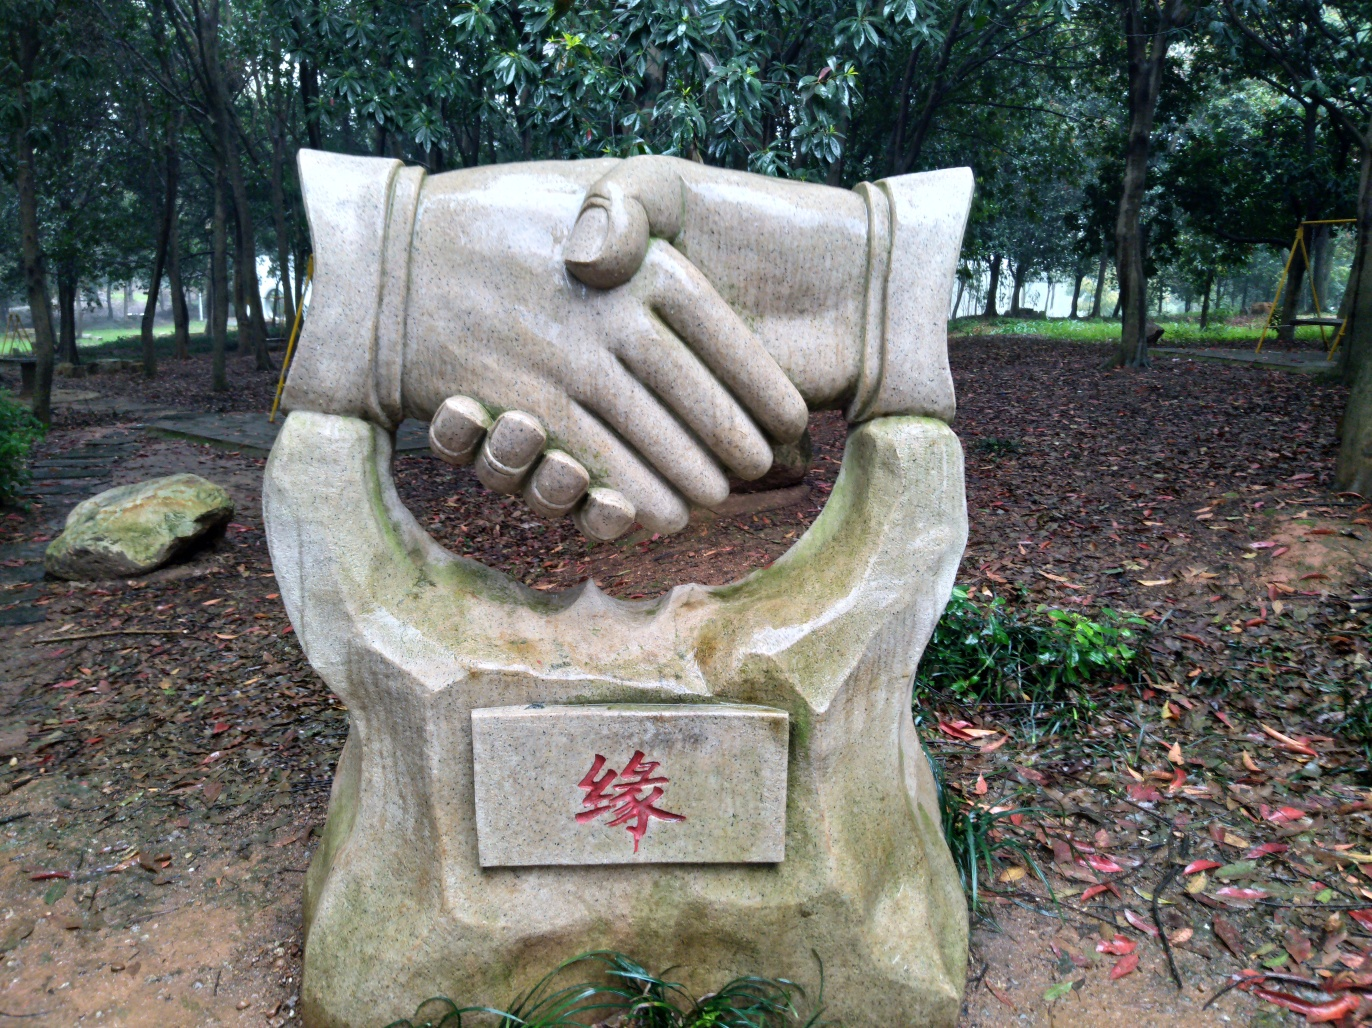Are the texture features of the sculpture clear?
A. Not visible
B. Slightly blurred
C. No
D. Yes
Answer with the option's letter from the given choices directly.
 D. 